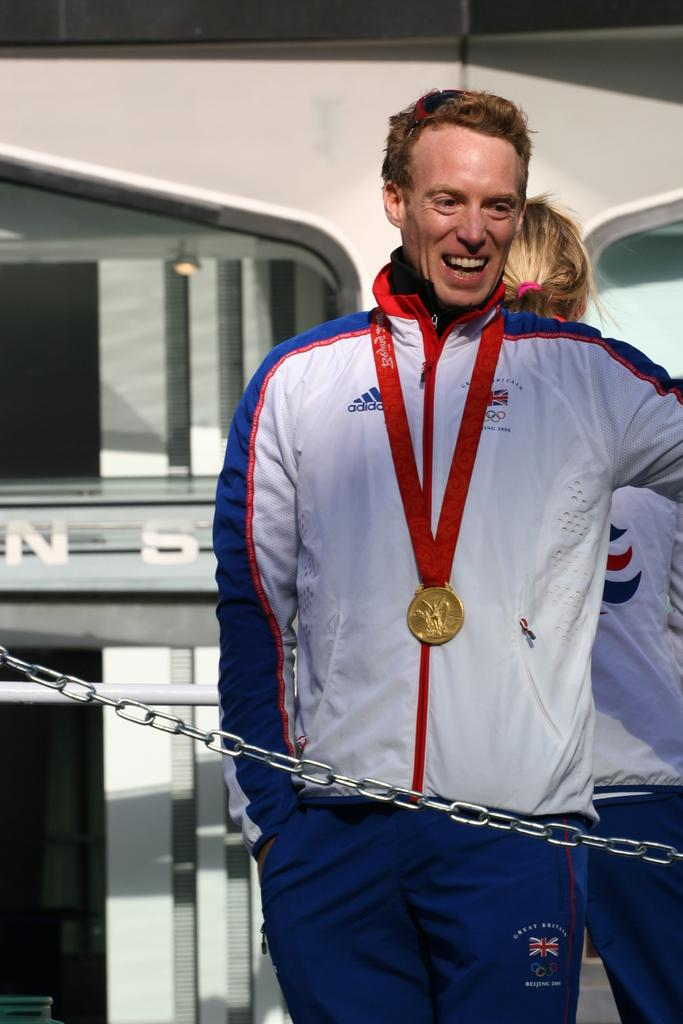What is the person in the image wearing? The person in the image is wearing a medal. What is the person standing in front of? The person is standing in front of a chain. Can you describe the other person in the image? There is another person standing on the right side of the image, and they are wearing clothes. What type of flame can be seen near the grandmother in the image? There is no grandmother or flame present in the image. 